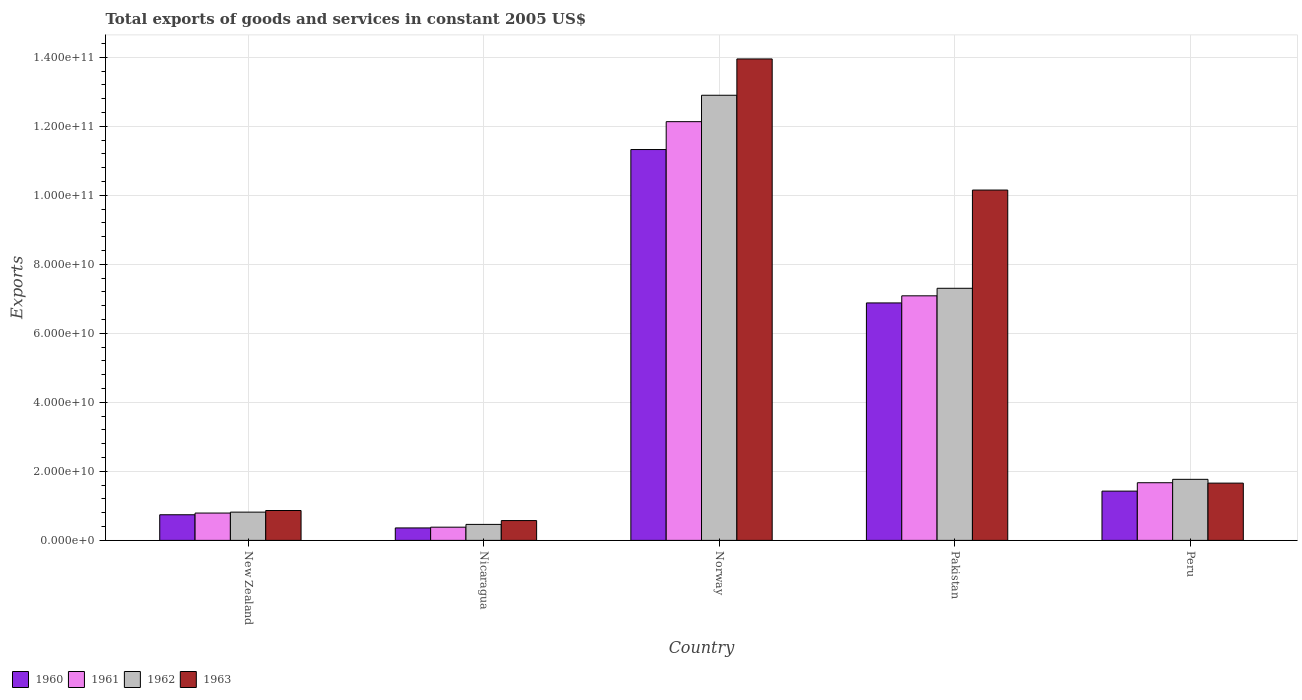Are the number of bars on each tick of the X-axis equal?
Provide a succinct answer. Yes. How many bars are there on the 4th tick from the right?
Keep it short and to the point. 4. What is the label of the 3rd group of bars from the left?
Offer a very short reply. Norway. In how many cases, is the number of bars for a given country not equal to the number of legend labels?
Your response must be concise. 0. What is the total exports of goods and services in 1962 in Peru?
Ensure brevity in your answer.  1.77e+1. Across all countries, what is the maximum total exports of goods and services in 1960?
Your answer should be very brief. 1.13e+11. Across all countries, what is the minimum total exports of goods and services in 1963?
Ensure brevity in your answer.  5.74e+09. In which country was the total exports of goods and services in 1961 minimum?
Provide a succinct answer. Nicaragua. What is the total total exports of goods and services in 1961 in the graph?
Make the answer very short. 2.21e+11. What is the difference between the total exports of goods and services in 1961 in New Zealand and that in Norway?
Offer a very short reply. -1.13e+11. What is the difference between the total exports of goods and services in 1960 in New Zealand and the total exports of goods and services in 1961 in Nicaragua?
Provide a succinct answer. 3.60e+09. What is the average total exports of goods and services in 1961 per country?
Give a very brief answer. 4.41e+1. What is the difference between the total exports of goods and services of/in 1963 and total exports of goods and services of/in 1960 in Nicaragua?
Offer a terse response. 2.13e+09. In how many countries, is the total exports of goods and services in 1960 greater than 60000000000 US$?
Make the answer very short. 2. What is the ratio of the total exports of goods and services in 1961 in Norway to that in Pakistan?
Your answer should be very brief. 1.71. What is the difference between the highest and the second highest total exports of goods and services in 1961?
Offer a very short reply. -1.05e+11. What is the difference between the highest and the lowest total exports of goods and services in 1960?
Give a very brief answer. 1.10e+11. In how many countries, is the total exports of goods and services in 1962 greater than the average total exports of goods and services in 1962 taken over all countries?
Provide a succinct answer. 2. Is the sum of the total exports of goods and services in 1963 in Norway and Peru greater than the maximum total exports of goods and services in 1960 across all countries?
Provide a succinct answer. Yes. What does the 4th bar from the left in Pakistan represents?
Your answer should be compact. 1963. How many bars are there?
Your answer should be very brief. 20. Are the values on the major ticks of Y-axis written in scientific E-notation?
Your answer should be very brief. Yes. Does the graph contain any zero values?
Your answer should be very brief. No. Where does the legend appear in the graph?
Ensure brevity in your answer.  Bottom left. How many legend labels are there?
Provide a short and direct response. 4. How are the legend labels stacked?
Make the answer very short. Horizontal. What is the title of the graph?
Give a very brief answer. Total exports of goods and services in constant 2005 US$. What is the label or title of the Y-axis?
Your answer should be very brief. Exports. What is the Exports of 1960 in New Zealand?
Ensure brevity in your answer.  7.43e+09. What is the Exports in 1961 in New Zealand?
Give a very brief answer. 7.92e+09. What is the Exports of 1962 in New Zealand?
Offer a terse response. 8.19e+09. What is the Exports in 1963 in New Zealand?
Keep it short and to the point. 8.66e+09. What is the Exports in 1960 in Nicaragua?
Offer a very short reply. 3.61e+09. What is the Exports of 1961 in Nicaragua?
Your response must be concise. 3.83e+09. What is the Exports in 1962 in Nicaragua?
Give a very brief answer. 4.64e+09. What is the Exports in 1963 in Nicaragua?
Keep it short and to the point. 5.74e+09. What is the Exports in 1960 in Norway?
Your answer should be compact. 1.13e+11. What is the Exports in 1961 in Norway?
Your answer should be very brief. 1.21e+11. What is the Exports of 1962 in Norway?
Keep it short and to the point. 1.29e+11. What is the Exports in 1963 in Norway?
Give a very brief answer. 1.40e+11. What is the Exports of 1960 in Pakistan?
Provide a short and direct response. 6.88e+1. What is the Exports of 1961 in Pakistan?
Offer a terse response. 7.09e+1. What is the Exports of 1962 in Pakistan?
Provide a succinct answer. 7.31e+1. What is the Exports of 1963 in Pakistan?
Your answer should be compact. 1.02e+11. What is the Exports of 1960 in Peru?
Give a very brief answer. 1.43e+1. What is the Exports in 1961 in Peru?
Offer a terse response. 1.67e+1. What is the Exports of 1962 in Peru?
Ensure brevity in your answer.  1.77e+1. What is the Exports in 1963 in Peru?
Offer a very short reply. 1.66e+1. Across all countries, what is the maximum Exports of 1960?
Your answer should be very brief. 1.13e+11. Across all countries, what is the maximum Exports in 1961?
Provide a succinct answer. 1.21e+11. Across all countries, what is the maximum Exports in 1962?
Provide a succinct answer. 1.29e+11. Across all countries, what is the maximum Exports in 1963?
Your answer should be compact. 1.40e+11. Across all countries, what is the minimum Exports in 1960?
Ensure brevity in your answer.  3.61e+09. Across all countries, what is the minimum Exports of 1961?
Provide a short and direct response. 3.83e+09. Across all countries, what is the minimum Exports in 1962?
Your response must be concise. 4.64e+09. Across all countries, what is the minimum Exports in 1963?
Provide a succinct answer. 5.74e+09. What is the total Exports of 1960 in the graph?
Ensure brevity in your answer.  2.07e+11. What is the total Exports of 1961 in the graph?
Ensure brevity in your answer.  2.21e+11. What is the total Exports in 1962 in the graph?
Ensure brevity in your answer.  2.33e+11. What is the total Exports of 1963 in the graph?
Provide a short and direct response. 2.72e+11. What is the difference between the Exports in 1960 in New Zealand and that in Nicaragua?
Make the answer very short. 3.82e+09. What is the difference between the Exports in 1961 in New Zealand and that in Nicaragua?
Make the answer very short. 4.10e+09. What is the difference between the Exports in 1962 in New Zealand and that in Nicaragua?
Give a very brief answer. 3.55e+09. What is the difference between the Exports of 1963 in New Zealand and that in Nicaragua?
Provide a short and direct response. 2.92e+09. What is the difference between the Exports in 1960 in New Zealand and that in Norway?
Provide a short and direct response. -1.06e+11. What is the difference between the Exports in 1961 in New Zealand and that in Norway?
Offer a very short reply. -1.13e+11. What is the difference between the Exports in 1962 in New Zealand and that in Norway?
Provide a short and direct response. -1.21e+11. What is the difference between the Exports in 1963 in New Zealand and that in Norway?
Your response must be concise. -1.31e+11. What is the difference between the Exports of 1960 in New Zealand and that in Pakistan?
Provide a short and direct response. -6.14e+1. What is the difference between the Exports of 1961 in New Zealand and that in Pakistan?
Keep it short and to the point. -6.29e+1. What is the difference between the Exports of 1962 in New Zealand and that in Pakistan?
Provide a short and direct response. -6.49e+1. What is the difference between the Exports in 1963 in New Zealand and that in Pakistan?
Your answer should be very brief. -9.29e+1. What is the difference between the Exports of 1960 in New Zealand and that in Peru?
Provide a short and direct response. -6.85e+09. What is the difference between the Exports of 1961 in New Zealand and that in Peru?
Offer a very short reply. -8.79e+09. What is the difference between the Exports in 1962 in New Zealand and that in Peru?
Make the answer very short. -9.50e+09. What is the difference between the Exports of 1963 in New Zealand and that in Peru?
Your answer should be very brief. -7.94e+09. What is the difference between the Exports of 1960 in Nicaragua and that in Norway?
Offer a terse response. -1.10e+11. What is the difference between the Exports of 1961 in Nicaragua and that in Norway?
Provide a short and direct response. -1.18e+11. What is the difference between the Exports in 1962 in Nicaragua and that in Norway?
Offer a terse response. -1.24e+11. What is the difference between the Exports of 1963 in Nicaragua and that in Norway?
Your answer should be very brief. -1.34e+11. What is the difference between the Exports of 1960 in Nicaragua and that in Pakistan?
Make the answer very short. -6.52e+1. What is the difference between the Exports in 1961 in Nicaragua and that in Pakistan?
Offer a terse response. -6.70e+1. What is the difference between the Exports in 1962 in Nicaragua and that in Pakistan?
Your response must be concise. -6.84e+1. What is the difference between the Exports in 1963 in Nicaragua and that in Pakistan?
Give a very brief answer. -9.58e+1. What is the difference between the Exports in 1960 in Nicaragua and that in Peru?
Your answer should be very brief. -1.07e+1. What is the difference between the Exports of 1961 in Nicaragua and that in Peru?
Offer a very short reply. -1.29e+1. What is the difference between the Exports in 1962 in Nicaragua and that in Peru?
Offer a very short reply. -1.31e+1. What is the difference between the Exports in 1963 in Nicaragua and that in Peru?
Keep it short and to the point. -1.09e+1. What is the difference between the Exports in 1960 in Norway and that in Pakistan?
Make the answer very short. 4.44e+1. What is the difference between the Exports of 1961 in Norway and that in Pakistan?
Keep it short and to the point. 5.05e+1. What is the difference between the Exports in 1962 in Norway and that in Pakistan?
Offer a very short reply. 5.59e+1. What is the difference between the Exports of 1963 in Norway and that in Pakistan?
Your response must be concise. 3.80e+1. What is the difference between the Exports of 1960 in Norway and that in Peru?
Your answer should be very brief. 9.90e+1. What is the difference between the Exports in 1961 in Norway and that in Peru?
Keep it short and to the point. 1.05e+11. What is the difference between the Exports in 1962 in Norway and that in Peru?
Your answer should be compact. 1.11e+11. What is the difference between the Exports of 1963 in Norway and that in Peru?
Ensure brevity in your answer.  1.23e+11. What is the difference between the Exports in 1960 in Pakistan and that in Peru?
Make the answer very short. 5.45e+1. What is the difference between the Exports of 1961 in Pakistan and that in Peru?
Your answer should be compact. 5.42e+1. What is the difference between the Exports of 1962 in Pakistan and that in Peru?
Keep it short and to the point. 5.54e+1. What is the difference between the Exports of 1963 in Pakistan and that in Peru?
Your answer should be very brief. 8.49e+1. What is the difference between the Exports of 1960 in New Zealand and the Exports of 1961 in Nicaragua?
Provide a succinct answer. 3.60e+09. What is the difference between the Exports in 1960 in New Zealand and the Exports in 1962 in Nicaragua?
Provide a short and direct response. 2.79e+09. What is the difference between the Exports of 1960 in New Zealand and the Exports of 1963 in Nicaragua?
Your answer should be compact. 1.68e+09. What is the difference between the Exports of 1961 in New Zealand and the Exports of 1962 in Nicaragua?
Offer a very short reply. 3.29e+09. What is the difference between the Exports of 1961 in New Zealand and the Exports of 1963 in Nicaragua?
Provide a succinct answer. 2.18e+09. What is the difference between the Exports in 1962 in New Zealand and the Exports in 1963 in Nicaragua?
Your answer should be compact. 2.45e+09. What is the difference between the Exports in 1960 in New Zealand and the Exports in 1961 in Norway?
Your response must be concise. -1.14e+11. What is the difference between the Exports in 1960 in New Zealand and the Exports in 1962 in Norway?
Ensure brevity in your answer.  -1.22e+11. What is the difference between the Exports in 1960 in New Zealand and the Exports in 1963 in Norway?
Offer a very short reply. -1.32e+11. What is the difference between the Exports of 1961 in New Zealand and the Exports of 1962 in Norway?
Give a very brief answer. -1.21e+11. What is the difference between the Exports of 1961 in New Zealand and the Exports of 1963 in Norway?
Ensure brevity in your answer.  -1.32e+11. What is the difference between the Exports of 1962 in New Zealand and the Exports of 1963 in Norway?
Offer a very short reply. -1.31e+11. What is the difference between the Exports of 1960 in New Zealand and the Exports of 1961 in Pakistan?
Your response must be concise. -6.34e+1. What is the difference between the Exports in 1960 in New Zealand and the Exports in 1962 in Pakistan?
Give a very brief answer. -6.56e+1. What is the difference between the Exports in 1960 in New Zealand and the Exports in 1963 in Pakistan?
Your response must be concise. -9.41e+1. What is the difference between the Exports of 1961 in New Zealand and the Exports of 1962 in Pakistan?
Offer a very short reply. -6.51e+1. What is the difference between the Exports in 1961 in New Zealand and the Exports in 1963 in Pakistan?
Offer a very short reply. -9.36e+1. What is the difference between the Exports of 1962 in New Zealand and the Exports of 1963 in Pakistan?
Give a very brief answer. -9.33e+1. What is the difference between the Exports of 1960 in New Zealand and the Exports of 1961 in Peru?
Give a very brief answer. -9.28e+09. What is the difference between the Exports in 1960 in New Zealand and the Exports in 1962 in Peru?
Offer a very short reply. -1.03e+1. What is the difference between the Exports in 1960 in New Zealand and the Exports in 1963 in Peru?
Ensure brevity in your answer.  -9.17e+09. What is the difference between the Exports of 1961 in New Zealand and the Exports of 1962 in Peru?
Provide a short and direct response. -9.77e+09. What is the difference between the Exports in 1961 in New Zealand and the Exports in 1963 in Peru?
Ensure brevity in your answer.  -8.67e+09. What is the difference between the Exports in 1962 in New Zealand and the Exports in 1963 in Peru?
Make the answer very short. -8.40e+09. What is the difference between the Exports in 1960 in Nicaragua and the Exports in 1961 in Norway?
Provide a short and direct response. -1.18e+11. What is the difference between the Exports of 1960 in Nicaragua and the Exports of 1962 in Norway?
Your answer should be compact. -1.25e+11. What is the difference between the Exports in 1960 in Nicaragua and the Exports in 1963 in Norway?
Ensure brevity in your answer.  -1.36e+11. What is the difference between the Exports of 1961 in Nicaragua and the Exports of 1962 in Norway?
Ensure brevity in your answer.  -1.25e+11. What is the difference between the Exports in 1961 in Nicaragua and the Exports in 1963 in Norway?
Your response must be concise. -1.36e+11. What is the difference between the Exports in 1962 in Nicaragua and the Exports in 1963 in Norway?
Keep it short and to the point. -1.35e+11. What is the difference between the Exports in 1960 in Nicaragua and the Exports in 1961 in Pakistan?
Your answer should be compact. -6.73e+1. What is the difference between the Exports of 1960 in Nicaragua and the Exports of 1962 in Pakistan?
Ensure brevity in your answer.  -6.94e+1. What is the difference between the Exports of 1960 in Nicaragua and the Exports of 1963 in Pakistan?
Your answer should be compact. -9.79e+1. What is the difference between the Exports in 1961 in Nicaragua and the Exports in 1962 in Pakistan?
Your answer should be compact. -6.92e+1. What is the difference between the Exports in 1961 in Nicaragua and the Exports in 1963 in Pakistan?
Make the answer very short. -9.77e+1. What is the difference between the Exports in 1962 in Nicaragua and the Exports in 1963 in Pakistan?
Provide a short and direct response. -9.69e+1. What is the difference between the Exports in 1960 in Nicaragua and the Exports in 1961 in Peru?
Your answer should be compact. -1.31e+1. What is the difference between the Exports in 1960 in Nicaragua and the Exports in 1962 in Peru?
Keep it short and to the point. -1.41e+1. What is the difference between the Exports in 1960 in Nicaragua and the Exports in 1963 in Peru?
Offer a very short reply. -1.30e+1. What is the difference between the Exports in 1961 in Nicaragua and the Exports in 1962 in Peru?
Your answer should be very brief. -1.39e+1. What is the difference between the Exports of 1961 in Nicaragua and the Exports of 1963 in Peru?
Make the answer very short. -1.28e+1. What is the difference between the Exports in 1962 in Nicaragua and the Exports in 1963 in Peru?
Offer a very short reply. -1.20e+1. What is the difference between the Exports of 1960 in Norway and the Exports of 1961 in Pakistan?
Ensure brevity in your answer.  4.24e+1. What is the difference between the Exports in 1960 in Norway and the Exports in 1962 in Pakistan?
Your response must be concise. 4.02e+1. What is the difference between the Exports in 1960 in Norway and the Exports in 1963 in Pakistan?
Provide a short and direct response. 1.17e+1. What is the difference between the Exports of 1961 in Norway and the Exports of 1962 in Pakistan?
Keep it short and to the point. 4.83e+1. What is the difference between the Exports in 1961 in Norway and the Exports in 1963 in Pakistan?
Ensure brevity in your answer.  1.98e+1. What is the difference between the Exports of 1962 in Norway and the Exports of 1963 in Pakistan?
Ensure brevity in your answer.  2.75e+1. What is the difference between the Exports in 1960 in Norway and the Exports in 1961 in Peru?
Your answer should be very brief. 9.65e+1. What is the difference between the Exports in 1960 in Norway and the Exports in 1962 in Peru?
Offer a terse response. 9.56e+1. What is the difference between the Exports of 1960 in Norway and the Exports of 1963 in Peru?
Offer a terse response. 9.67e+1. What is the difference between the Exports of 1961 in Norway and the Exports of 1962 in Peru?
Give a very brief answer. 1.04e+11. What is the difference between the Exports of 1961 in Norway and the Exports of 1963 in Peru?
Give a very brief answer. 1.05e+11. What is the difference between the Exports of 1962 in Norway and the Exports of 1963 in Peru?
Your answer should be very brief. 1.12e+11. What is the difference between the Exports of 1960 in Pakistan and the Exports of 1961 in Peru?
Give a very brief answer. 5.21e+1. What is the difference between the Exports in 1960 in Pakistan and the Exports in 1962 in Peru?
Make the answer very short. 5.11e+1. What is the difference between the Exports of 1960 in Pakistan and the Exports of 1963 in Peru?
Your response must be concise. 5.22e+1. What is the difference between the Exports of 1961 in Pakistan and the Exports of 1962 in Peru?
Your answer should be compact. 5.32e+1. What is the difference between the Exports in 1961 in Pakistan and the Exports in 1963 in Peru?
Ensure brevity in your answer.  5.43e+1. What is the difference between the Exports of 1962 in Pakistan and the Exports of 1963 in Peru?
Your answer should be compact. 5.65e+1. What is the average Exports in 1960 per country?
Your answer should be very brief. 4.15e+1. What is the average Exports of 1961 per country?
Your answer should be very brief. 4.41e+1. What is the average Exports in 1962 per country?
Offer a very short reply. 4.65e+1. What is the average Exports in 1963 per country?
Keep it short and to the point. 5.44e+1. What is the difference between the Exports in 1960 and Exports in 1961 in New Zealand?
Provide a succinct answer. -4.96e+08. What is the difference between the Exports in 1960 and Exports in 1962 in New Zealand?
Your response must be concise. -7.63e+08. What is the difference between the Exports in 1960 and Exports in 1963 in New Zealand?
Give a very brief answer. -1.23e+09. What is the difference between the Exports of 1961 and Exports of 1962 in New Zealand?
Offer a very short reply. -2.67e+08. What is the difference between the Exports in 1961 and Exports in 1963 in New Zealand?
Make the answer very short. -7.36e+08. What is the difference between the Exports in 1962 and Exports in 1963 in New Zealand?
Ensure brevity in your answer.  -4.69e+08. What is the difference between the Exports in 1960 and Exports in 1961 in Nicaragua?
Provide a short and direct response. -2.16e+08. What is the difference between the Exports of 1960 and Exports of 1962 in Nicaragua?
Your response must be concise. -1.02e+09. What is the difference between the Exports of 1960 and Exports of 1963 in Nicaragua?
Your answer should be very brief. -2.13e+09. What is the difference between the Exports in 1961 and Exports in 1962 in Nicaragua?
Provide a succinct answer. -8.09e+08. What is the difference between the Exports in 1961 and Exports in 1963 in Nicaragua?
Your answer should be compact. -1.92e+09. What is the difference between the Exports in 1962 and Exports in 1963 in Nicaragua?
Offer a very short reply. -1.11e+09. What is the difference between the Exports in 1960 and Exports in 1961 in Norway?
Your answer should be compact. -8.08e+09. What is the difference between the Exports in 1960 and Exports in 1962 in Norway?
Ensure brevity in your answer.  -1.57e+1. What is the difference between the Exports of 1960 and Exports of 1963 in Norway?
Keep it short and to the point. -2.63e+1. What is the difference between the Exports in 1961 and Exports in 1962 in Norway?
Your answer should be very brief. -7.65e+09. What is the difference between the Exports in 1961 and Exports in 1963 in Norway?
Offer a very short reply. -1.82e+1. What is the difference between the Exports of 1962 and Exports of 1963 in Norway?
Your answer should be compact. -1.05e+1. What is the difference between the Exports in 1960 and Exports in 1961 in Pakistan?
Ensure brevity in your answer.  -2.06e+09. What is the difference between the Exports of 1960 and Exports of 1962 in Pakistan?
Offer a very short reply. -4.24e+09. What is the difference between the Exports of 1960 and Exports of 1963 in Pakistan?
Your answer should be compact. -3.27e+1. What is the difference between the Exports of 1961 and Exports of 1962 in Pakistan?
Give a very brief answer. -2.18e+09. What is the difference between the Exports of 1961 and Exports of 1963 in Pakistan?
Provide a short and direct response. -3.06e+1. What is the difference between the Exports in 1962 and Exports in 1963 in Pakistan?
Keep it short and to the point. -2.85e+1. What is the difference between the Exports in 1960 and Exports in 1961 in Peru?
Offer a very short reply. -2.43e+09. What is the difference between the Exports in 1960 and Exports in 1962 in Peru?
Offer a terse response. -3.42e+09. What is the difference between the Exports in 1960 and Exports in 1963 in Peru?
Your response must be concise. -2.32e+09. What is the difference between the Exports in 1961 and Exports in 1962 in Peru?
Your answer should be compact. -9.83e+08. What is the difference between the Exports of 1961 and Exports of 1963 in Peru?
Your answer should be very brief. 1.16e+08. What is the difference between the Exports in 1962 and Exports in 1963 in Peru?
Your answer should be very brief. 1.10e+09. What is the ratio of the Exports of 1960 in New Zealand to that in Nicaragua?
Your answer should be very brief. 2.06. What is the ratio of the Exports of 1961 in New Zealand to that in Nicaragua?
Make the answer very short. 2.07. What is the ratio of the Exports in 1962 in New Zealand to that in Nicaragua?
Provide a short and direct response. 1.77. What is the ratio of the Exports of 1963 in New Zealand to that in Nicaragua?
Your answer should be very brief. 1.51. What is the ratio of the Exports in 1960 in New Zealand to that in Norway?
Give a very brief answer. 0.07. What is the ratio of the Exports in 1961 in New Zealand to that in Norway?
Provide a succinct answer. 0.07. What is the ratio of the Exports of 1962 in New Zealand to that in Norway?
Make the answer very short. 0.06. What is the ratio of the Exports of 1963 in New Zealand to that in Norway?
Give a very brief answer. 0.06. What is the ratio of the Exports in 1960 in New Zealand to that in Pakistan?
Make the answer very short. 0.11. What is the ratio of the Exports in 1961 in New Zealand to that in Pakistan?
Your answer should be compact. 0.11. What is the ratio of the Exports of 1962 in New Zealand to that in Pakistan?
Keep it short and to the point. 0.11. What is the ratio of the Exports in 1963 in New Zealand to that in Pakistan?
Your answer should be very brief. 0.09. What is the ratio of the Exports of 1960 in New Zealand to that in Peru?
Your answer should be very brief. 0.52. What is the ratio of the Exports of 1961 in New Zealand to that in Peru?
Keep it short and to the point. 0.47. What is the ratio of the Exports of 1962 in New Zealand to that in Peru?
Offer a very short reply. 0.46. What is the ratio of the Exports in 1963 in New Zealand to that in Peru?
Your response must be concise. 0.52. What is the ratio of the Exports of 1960 in Nicaragua to that in Norway?
Offer a very short reply. 0.03. What is the ratio of the Exports in 1961 in Nicaragua to that in Norway?
Offer a very short reply. 0.03. What is the ratio of the Exports of 1962 in Nicaragua to that in Norway?
Give a very brief answer. 0.04. What is the ratio of the Exports in 1963 in Nicaragua to that in Norway?
Provide a succinct answer. 0.04. What is the ratio of the Exports of 1960 in Nicaragua to that in Pakistan?
Provide a short and direct response. 0.05. What is the ratio of the Exports in 1961 in Nicaragua to that in Pakistan?
Offer a very short reply. 0.05. What is the ratio of the Exports in 1962 in Nicaragua to that in Pakistan?
Make the answer very short. 0.06. What is the ratio of the Exports of 1963 in Nicaragua to that in Pakistan?
Provide a short and direct response. 0.06. What is the ratio of the Exports of 1960 in Nicaragua to that in Peru?
Make the answer very short. 0.25. What is the ratio of the Exports of 1961 in Nicaragua to that in Peru?
Provide a succinct answer. 0.23. What is the ratio of the Exports of 1962 in Nicaragua to that in Peru?
Your answer should be very brief. 0.26. What is the ratio of the Exports of 1963 in Nicaragua to that in Peru?
Make the answer very short. 0.35. What is the ratio of the Exports of 1960 in Norway to that in Pakistan?
Your answer should be compact. 1.65. What is the ratio of the Exports in 1961 in Norway to that in Pakistan?
Offer a very short reply. 1.71. What is the ratio of the Exports of 1962 in Norway to that in Pakistan?
Give a very brief answer. 1.77. What is the ratio of the Exports of 1963 in Norway to that in Pakistan?
Make the answer very short. 1.37. What is the ratio of the Exports in 1960 in Norway to that in Peru?
Your answer should be compact. 7.93. What is the ratio of the Exports of 1961 in Norway to that in Peru?
Offer a terse response. 7.26. What is the ratio of the Exports in 1962 in Norway to that in Peru?
Provide a short and direct response. 7.29. What is the ratio of the Exports of 1963 in Norway to that in Peru?
Your answer should be compact. 8.41. What is the ratio of the Exports of 1960 in Pakistan to that in Peru?
Make the answer very short. 4.82. What is the ratio of the Exports of 1961 in Pakistan to that in Peru?
Offer a very short reply. 4.24. What is the ratio of the Exports of 1962 in Pakistan to that in Peru?
Keep it short and to the point. 4.13. What is the ratio of the Exports of 1963 in Pakistan to that in Peru?
Offer a terse response. 6.12. What is the difference between the highest and the second highest Exports of 1960?
Offer a very short reply. 4.44e+1. What is the difference between the highest and the second highest Exports of 1961?
Your response must be concise. 5.05e+1. What is the difference between the highest and the second highest Exports of 1962?
Your answer should be compact. 5.59e+1. What is the difference between the highest and the second highest Exports of 1963?
Give a very brief answer. 3.80e+1. What is the difference between the highest and the lowest Exports in 1960?
Provide a short and direct response. 1.10e+11. What is the difference between the highest and the lowest Exports of 1961?
Offer a terse response. 1.18e+11. What is the difference between the highest and the lowest Exports in 1962?
Your answer should be very brief. 1.24e+11. What is the difference between the highest and the lowest Exports in 1963?
Provide a succinct answer. 1.34e+11. 